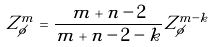<formula> <loc_0><loc_0><loc_500><loc_500>Z _ { \phi } ^ { m } = \frac { m + n - 2 } { m + n - 2 - k } Z _ { \phi } ^ { m - k }</formula> 